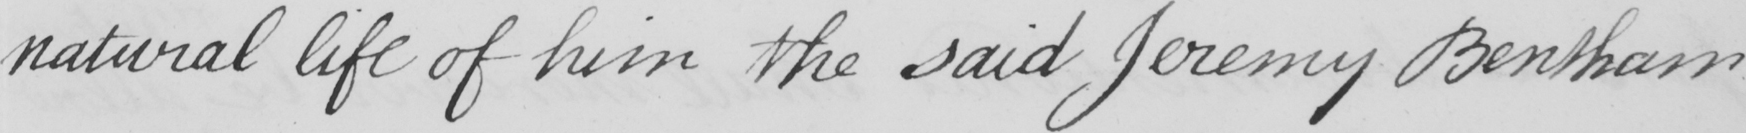Can you read and transcribe this handwriting? natural life of him the said Jeremy Bentham 